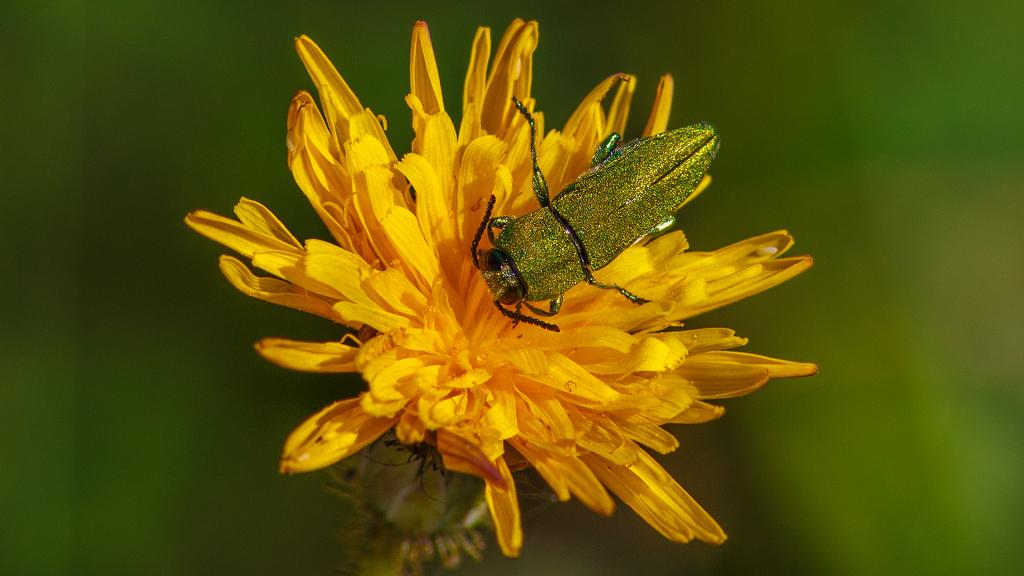What type of creature is present in the image? There is an insect in the image. Where is the insect located? The insect is on a flower. Can you describe the background of the image? The background of the image is blurred. What distance does the worm travel in the image? There is no worm present in the image, so it is not possible to determine the distance it might travel. 